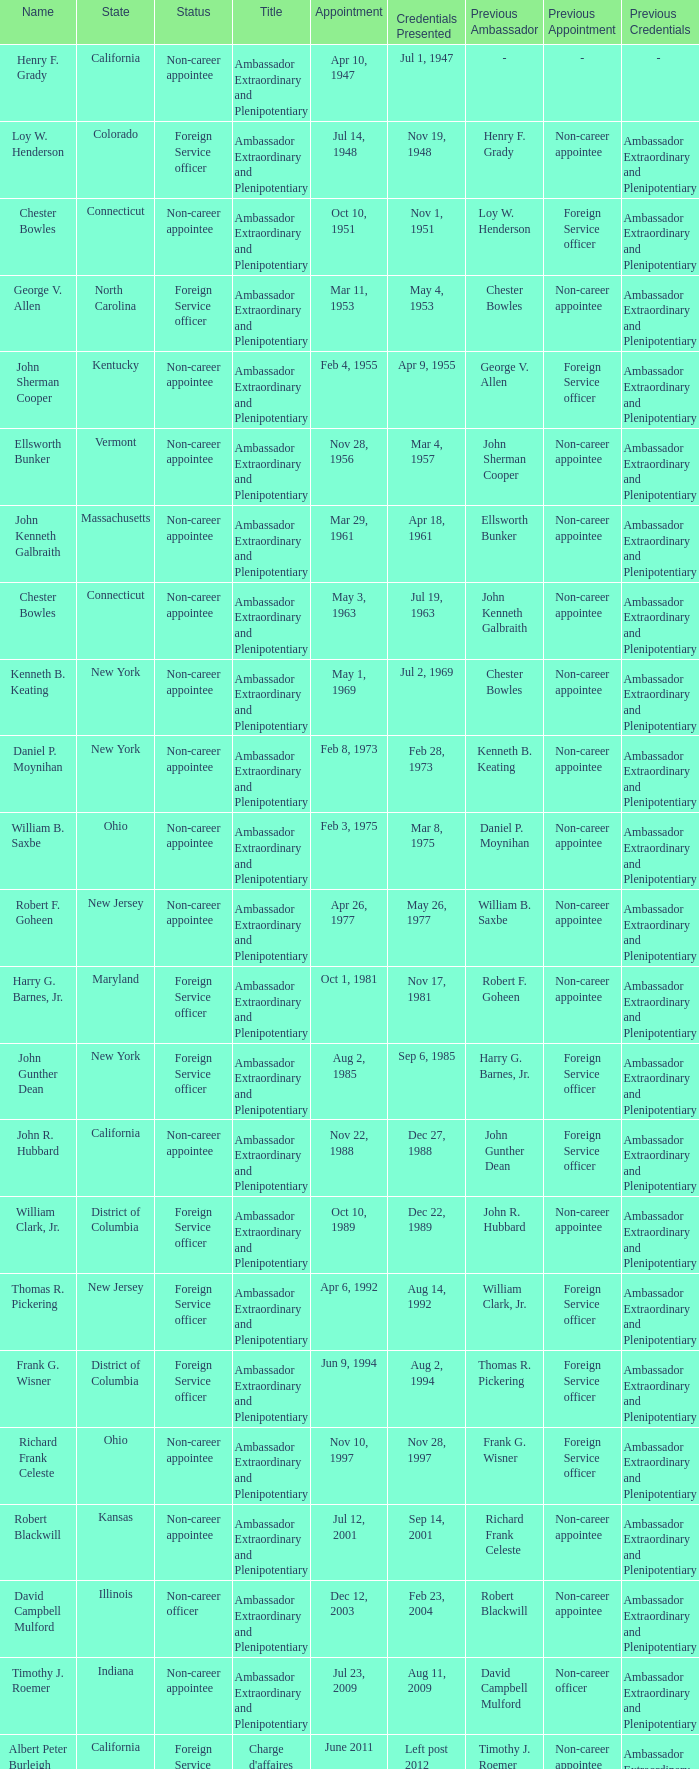On which day were the credentials for vermont presented? Mar 4, 1957. 